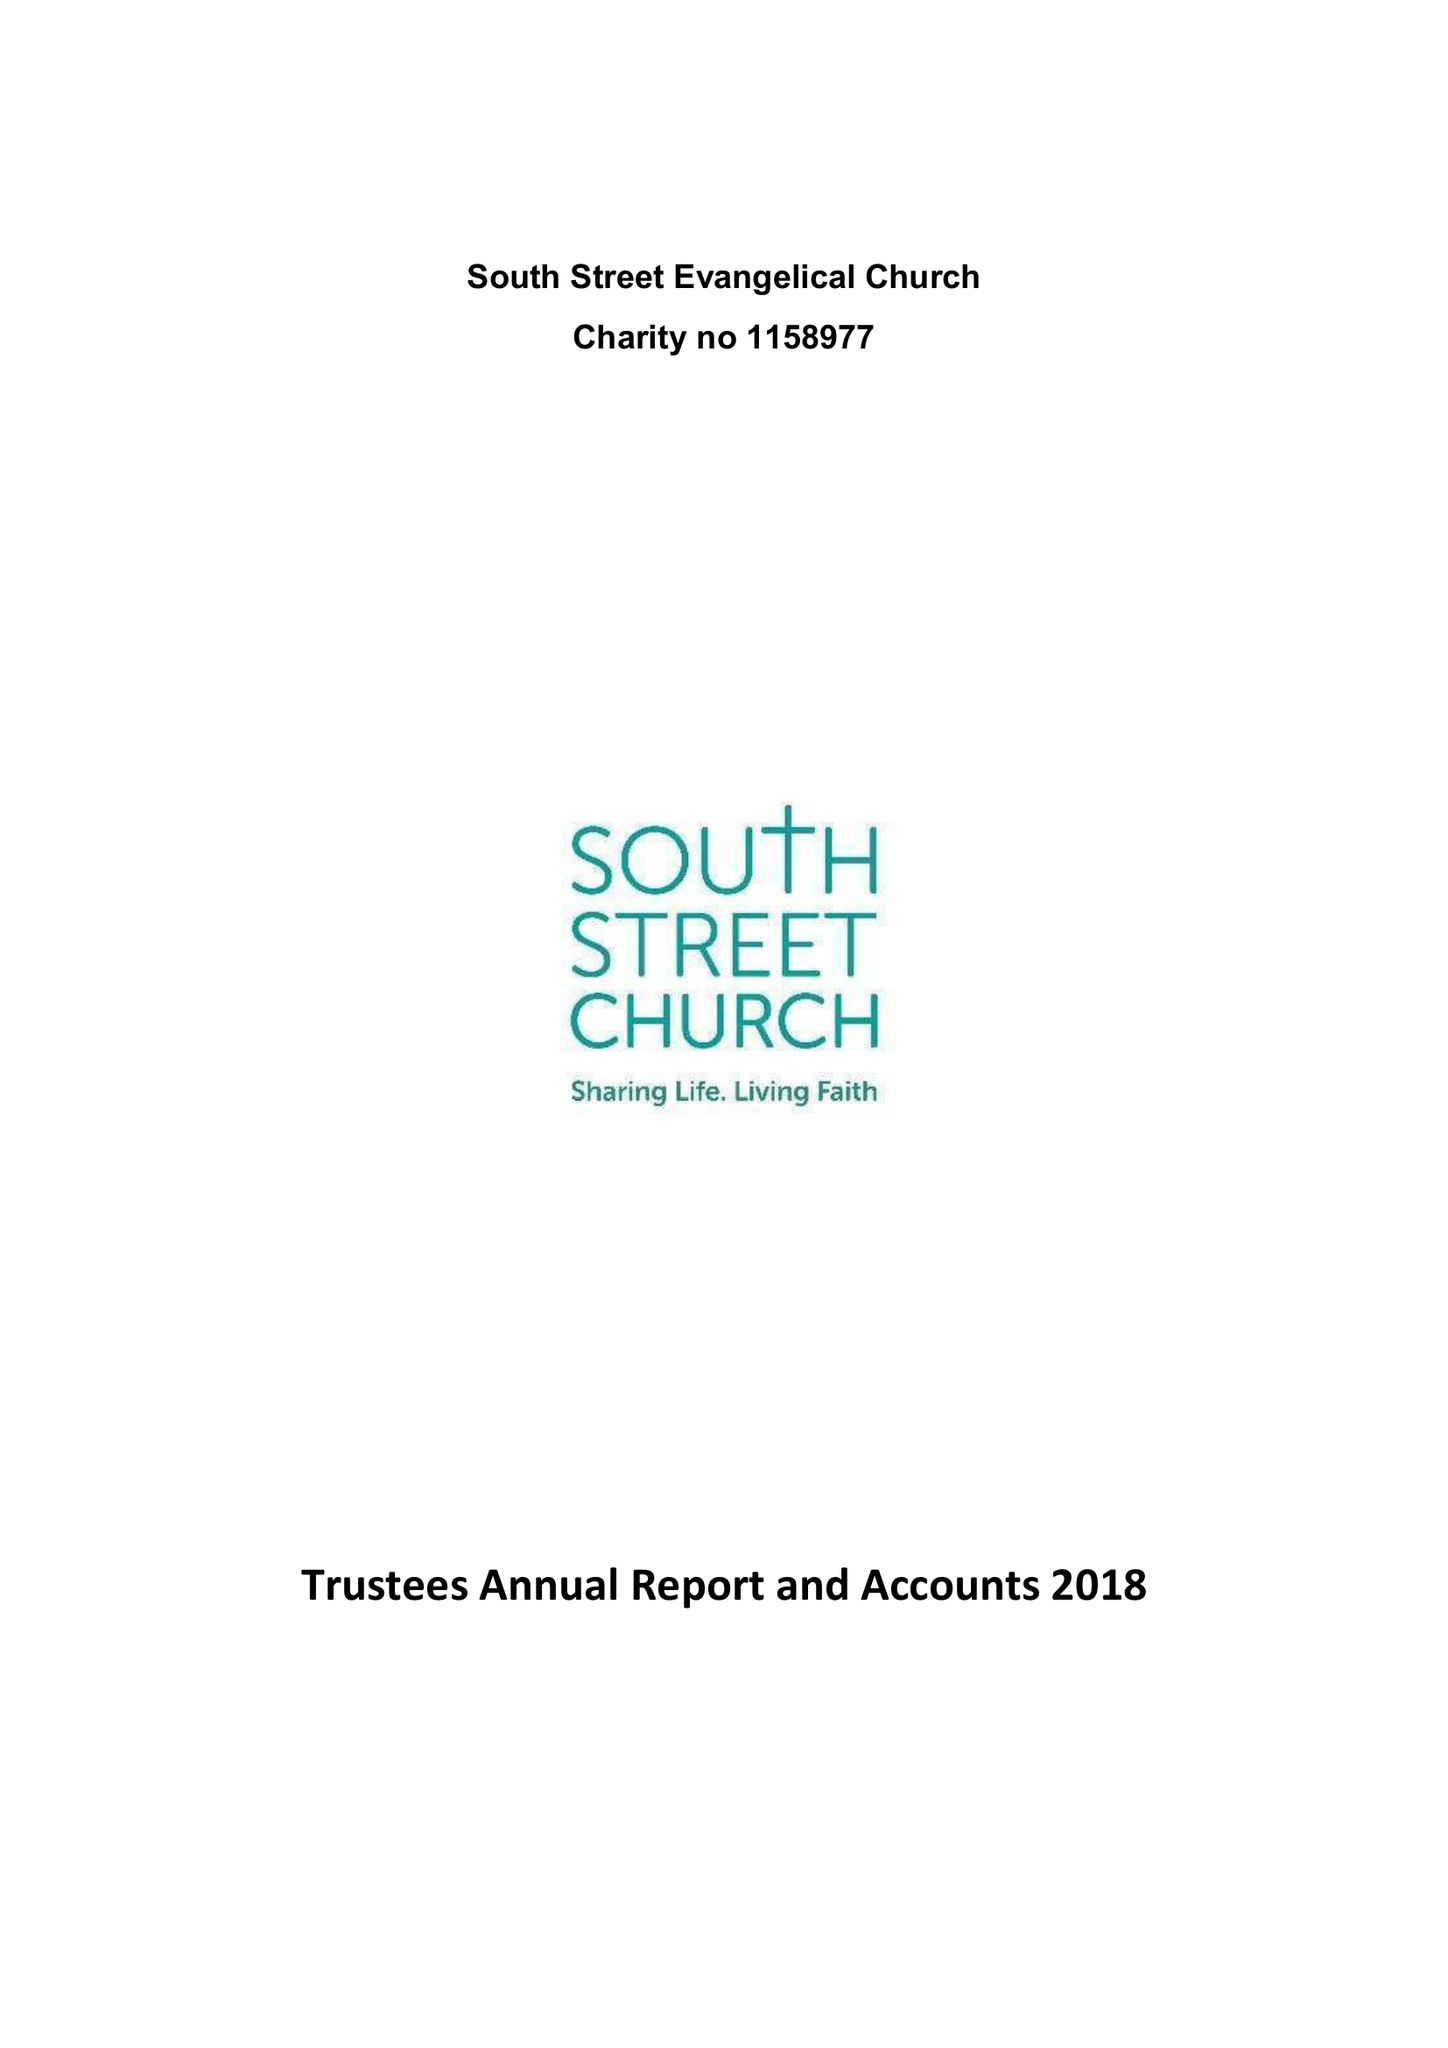What is the value for the address__postcode?
Answer the question using a single word or phrase. EX33 2AS 